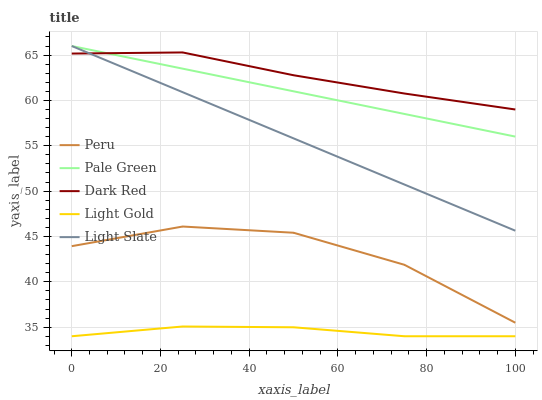Does Pale Green have the minimum area under the curve?
Answer yes or no. No. Does Pale Green have the maximum area under the curve?
Answer yes or no. No. Is Dark Red the smoothest?
Answer yes or no. No. Is Dark Red the roughest?
Answer yes or no. No. Does Pale Green have the lowest value?
Answer yes or no. No. Does Dark Red have the highest value?
Answer yes or no. No. Is Light Gold less than Dark Red?
Answer yes or no. Yes. Is Peru greater than Light Gold?
Answer yes or no. Yes. Does Light Gold intersect Dark Red?
Answer yes or no. No. 